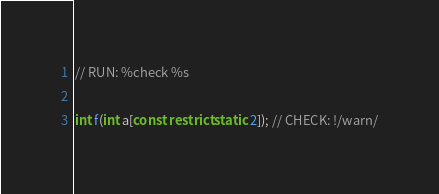Convert code to text. <code><loc_0><loc_0><loc_500><loc_500><_C_>// RUN: %check %s

int f(int a[const restrict static 2]); // CHECK: !/warn/
</code> 